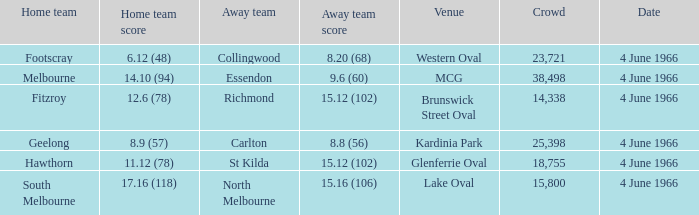What is the score of the away team that played home team Geelong? 8.8 (56). 